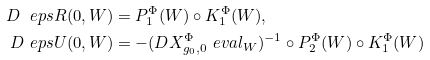Convert formula to latex. <formula><loc_0><loc_0><loc_500><loc_500>D _ { \ } e p s R ( 0 , W ) & = P _ { 1 } ^ { \Phi } ( W ) \circ K _ { 1 } ^ { \Phi } ( W ) , \\ D _ { \ } e p s U ( 0 , W ) & = - ( D X _ { g _ { 0 } , 0 } ^ { \Phi } \ e v a l _ { W } ) ^ { - 1 } \circ P _ { 2 } ^ { \Phi } ( W ) \circ K _ { 1 } ^ { \Phi } ( W )</formula> 